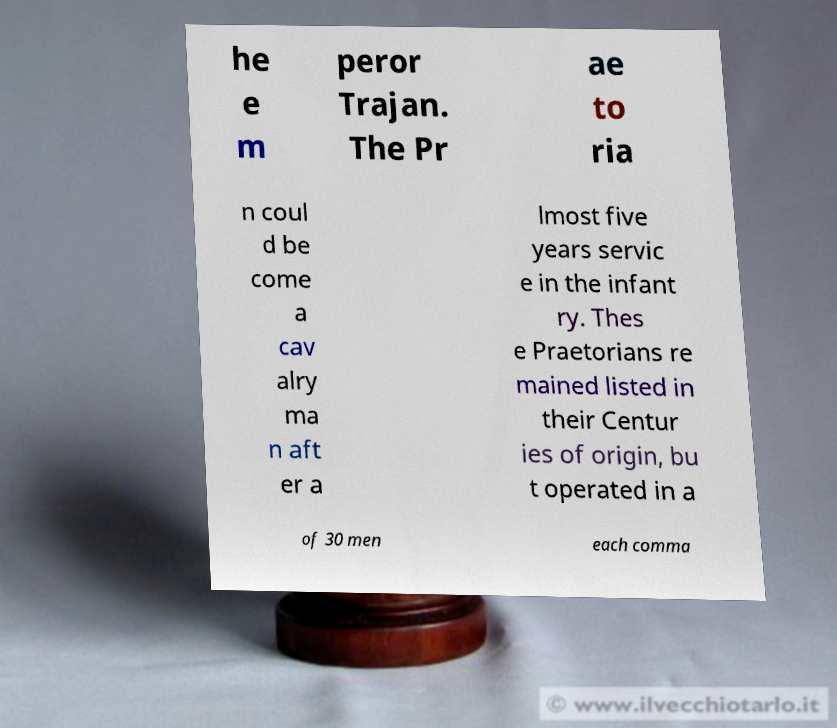For documentation purposes, I need the text within this image transcribed. Could you provide that? he e m peror Trajan. The Pr ae to ria n coul d be come a cav alry ma n aft er a lmost five years servic e in the infant ry. Thes e Praetorians re mained listed in their Centur ies of origin, bu t operated in a of 30 men each comma 